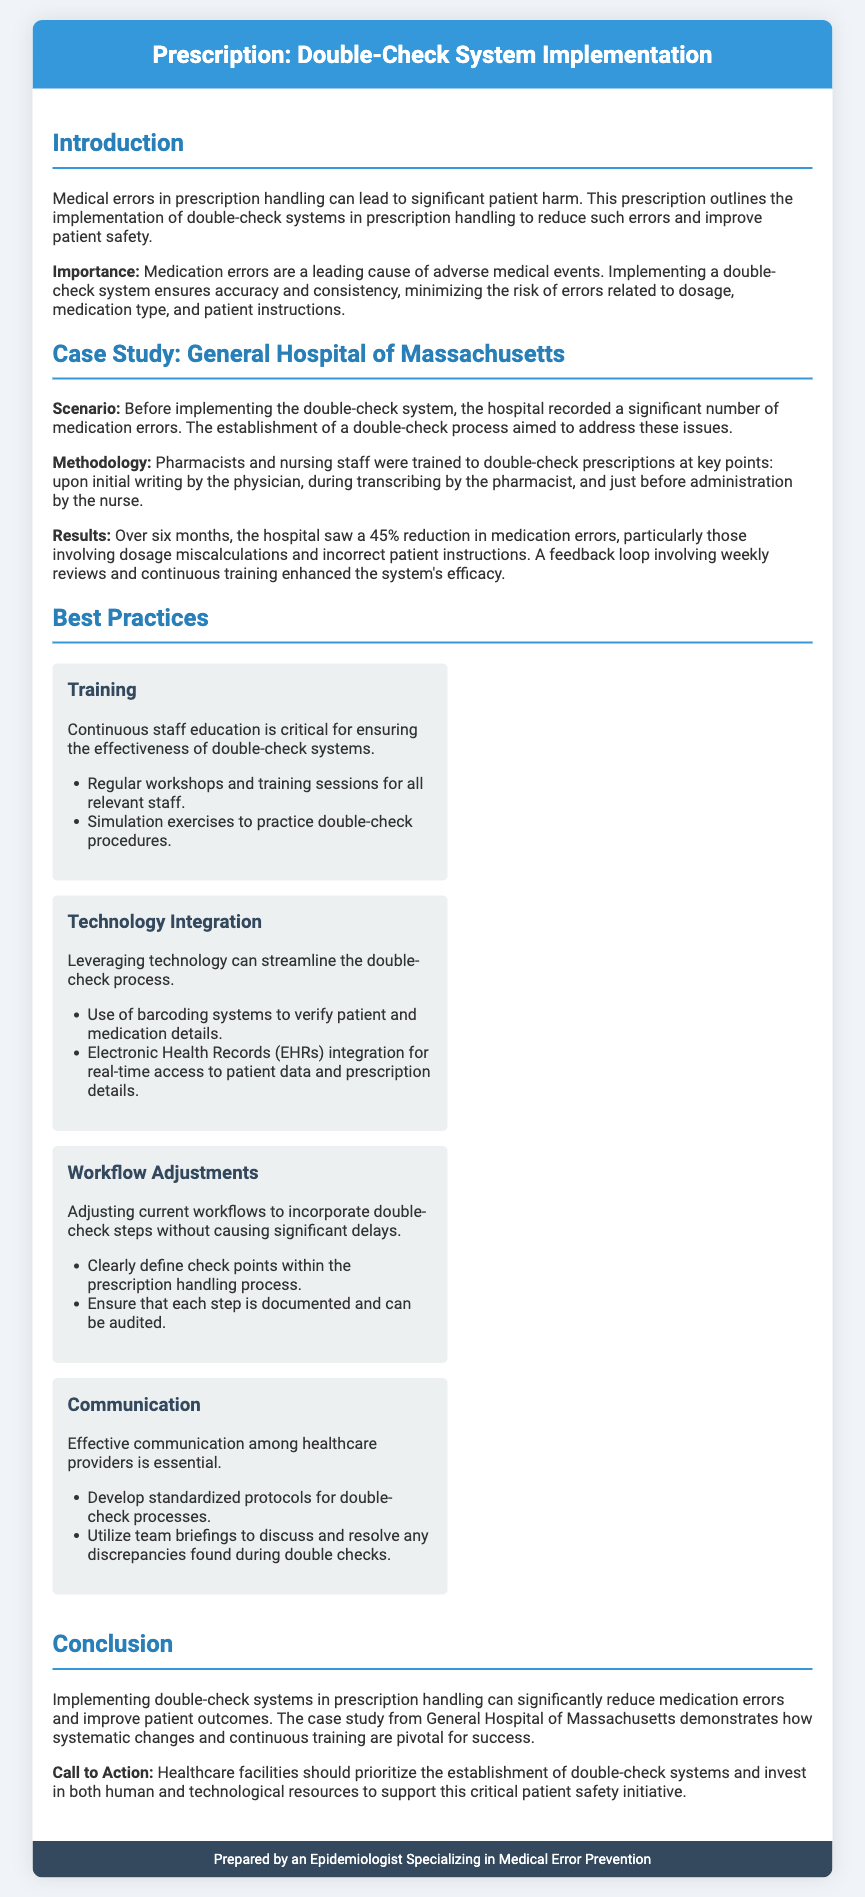What is the main goal of implementing double-check systems? The main goal of implementing double-check systems is to reduce medical errors and improve patient safety.
Answer: reduce medical errors and improve patient safety What percentage reduction in medication errors was observed in the case study? The case study indicated a 45% reduction in medication errors after implementing the double-check system.
Answer: 45% Which hospital is mentioned in the case study? The hospital featured in the case study is the General Hospital of Massachusetts.
Answer: General Hospital of Massachusetts Name one of the best practices for training staff. One of the best practices for training staff is to conduct regular workshops and training sessions.
Answer: regular workshops and training sessions What technological integration is suggested to streamline double-check processes? The document suggests the use of barcoding systems to verify patient and medication details as a technological integration.
Answer: barcoding systems How many key points of double-checking are mentioned in the methodology? The methodology includes three key points of double-checking: initial writing, transcribing, and before administration.
Answer: three What is a critical aspect of effective communication among healthcare providers? Developing standardized protocols for double-check processes is a critical aspect of effective communication.
Answer: standardized protocols What is highlighted as essential for staff training effectiveness? Continuous staff education is highlighted as essential for ensuring effectiveness.
Answer: Continuous staff education 